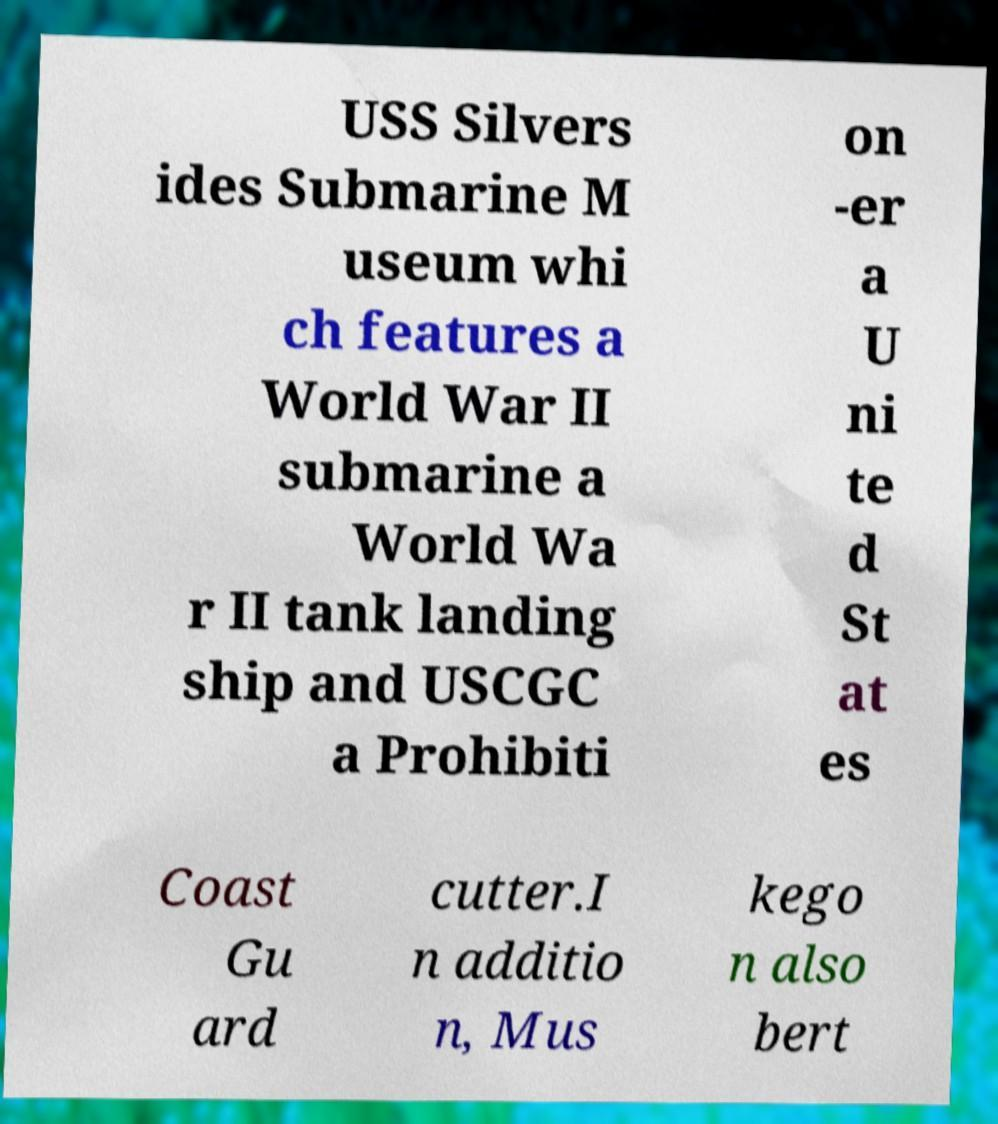Could you assist in decoding the text presented in this image and type it out clearly? USS Silvers ides Submarine M useum whi ch features a World War II submarine a World Wa r II tank landing ship and USCGC a Prohibiti on -er a U ni te d St at es Coast Gu ard cutter.I n additio n, Mus kego n also bert 